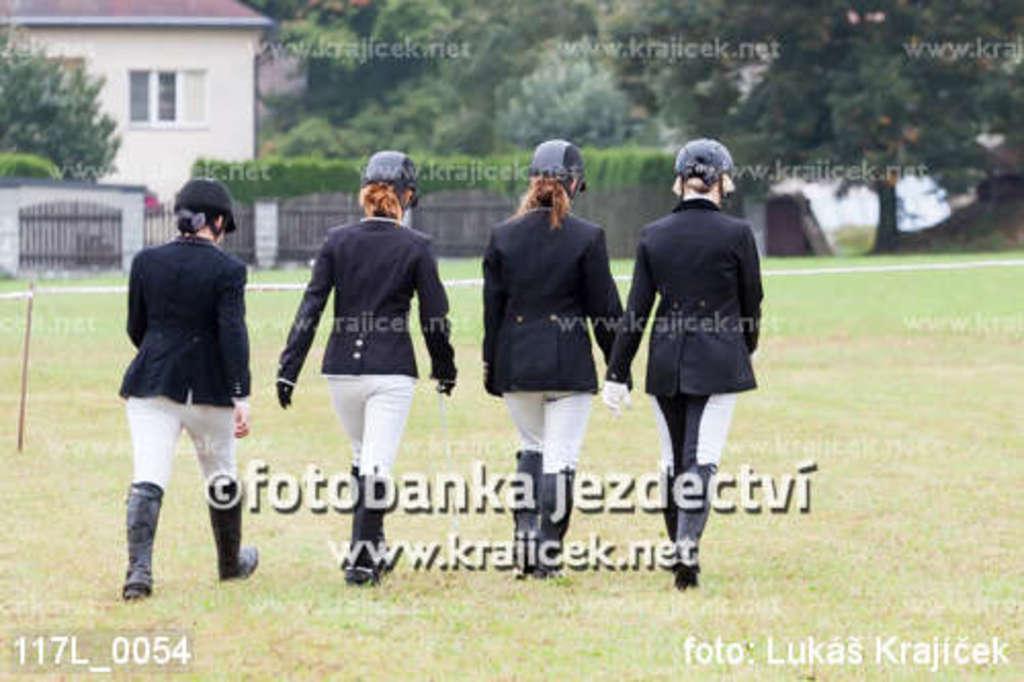In one or two sentences, can you explain what this image depicts? There are four women walking. This is a gate. I can see the trees and bushes. This looks like a house with a window. Here is a grass. I can see the watermarks on the image. 